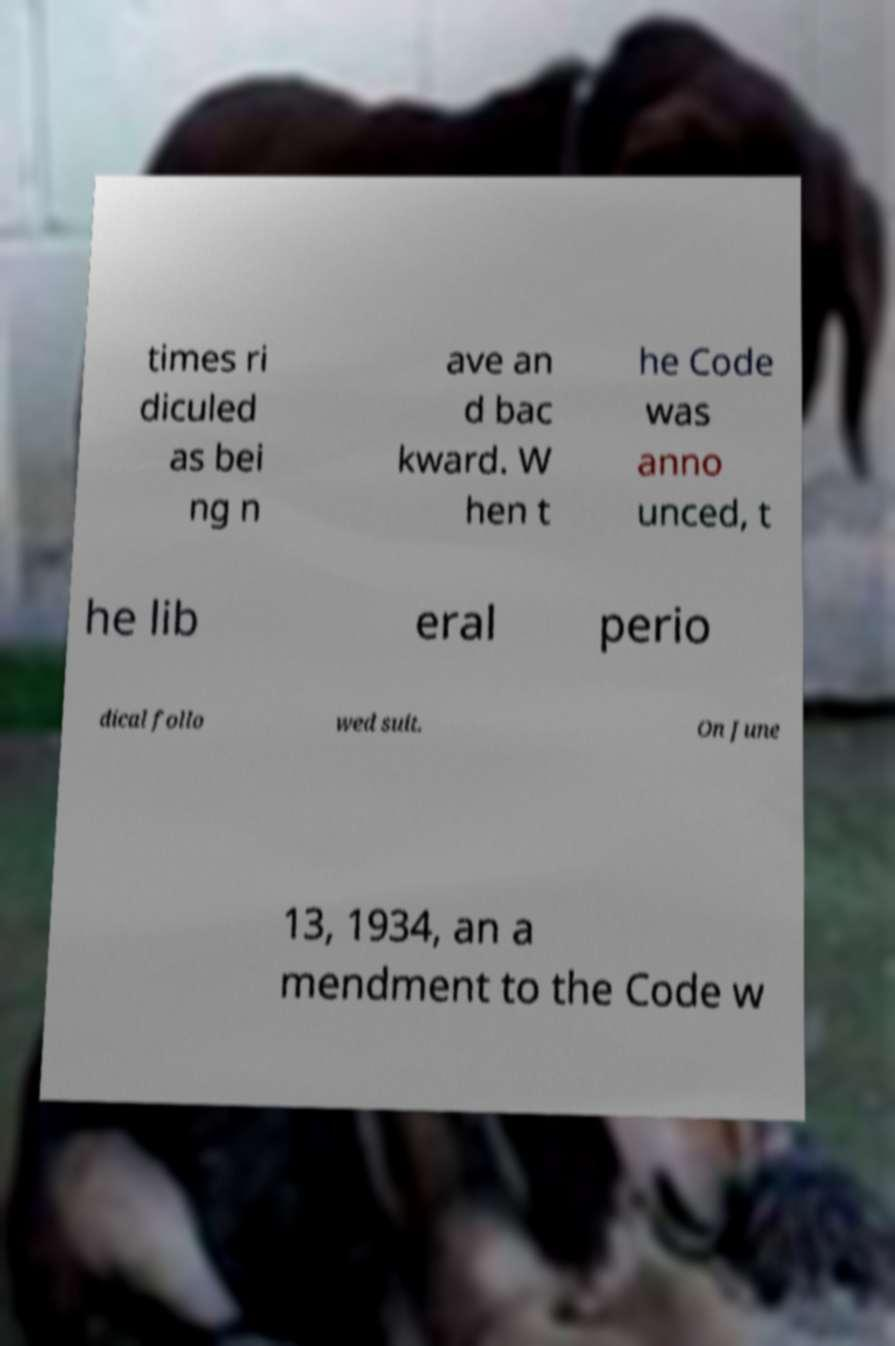What messages or text are displayed in this image? I need them in a readable, typed format. times ri diculed as bei ng n ave an d bac kward. W hen t he Code was anno unced, t he lib eral perio dical follo wed suit. On June 13, 1934, an a mendment to the Code w 